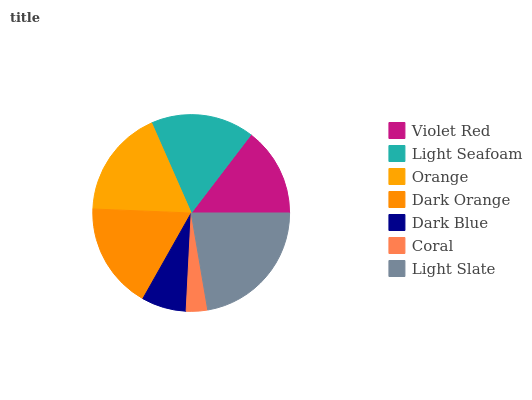Is Coral the minimum?
Answer yes or no. Yes. Is Light Slate the maximum?
Answer yes or no. Yes. Is Light Seafoam the minimum?
Answer yes or no. No. Is Light Seafoam the maximum?
Answer yes or no. No. Is Light Seafoam greater than Violet Red?
Answer yes or no. Yes. Is Violet Red less than Light Seafoam?
Answer yes or no. Yes. Is Violet Red greater than Light Seafoam?
Answer yes or no. No. Is Light Seafoam less than Violet Red?
Answer yes or no. No. Is Light Seafoam the high median?
Answer yes or no. Yes. Is Light Seafoam the low median?
Answer yes or no. Yes. Is Dark Blue the high median?
Answer yes or no. No. Is Violet Red the low median?
Answer yes or no. No. 